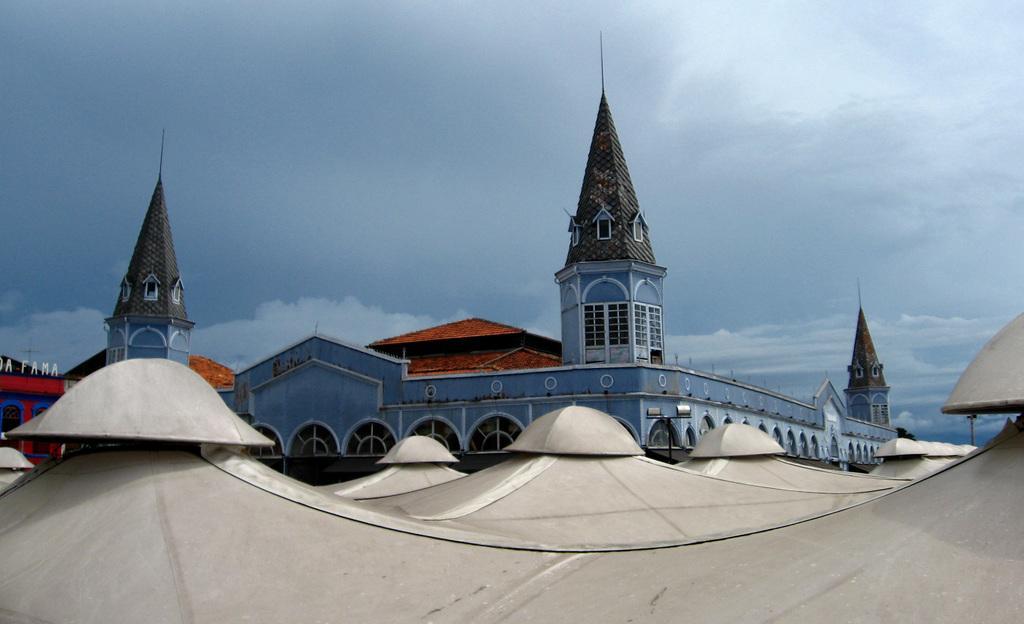Describe this image in one or two sentences. In this image there is a big building and iron shed in front of that. 